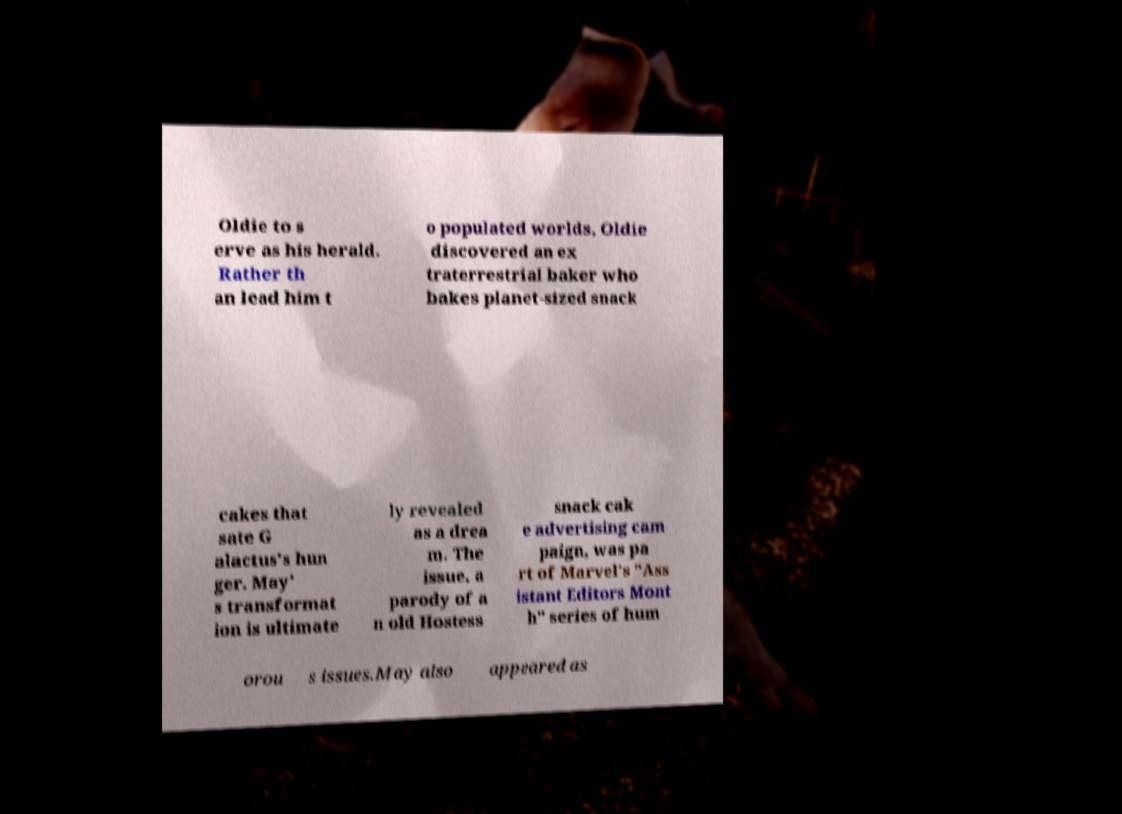For documentation purposes, I need the text within this image transcribed. Could you provide that? Oldie to s erve as his herald. Rather th an lead him t o populated worlds, Oldie discovered an ex traterrestrial baker who bakes planet-sized snack cakes that sate G alactus's hun ger. May' s transformat ion is ultimate ly revealed as a drea m. The issue, a parody of a n old Hostess snack cak e advertising cam paign, was pa rt of Marvel's "Ass istant Editors Mont h" series of hum orou s issues.May also appeared as 